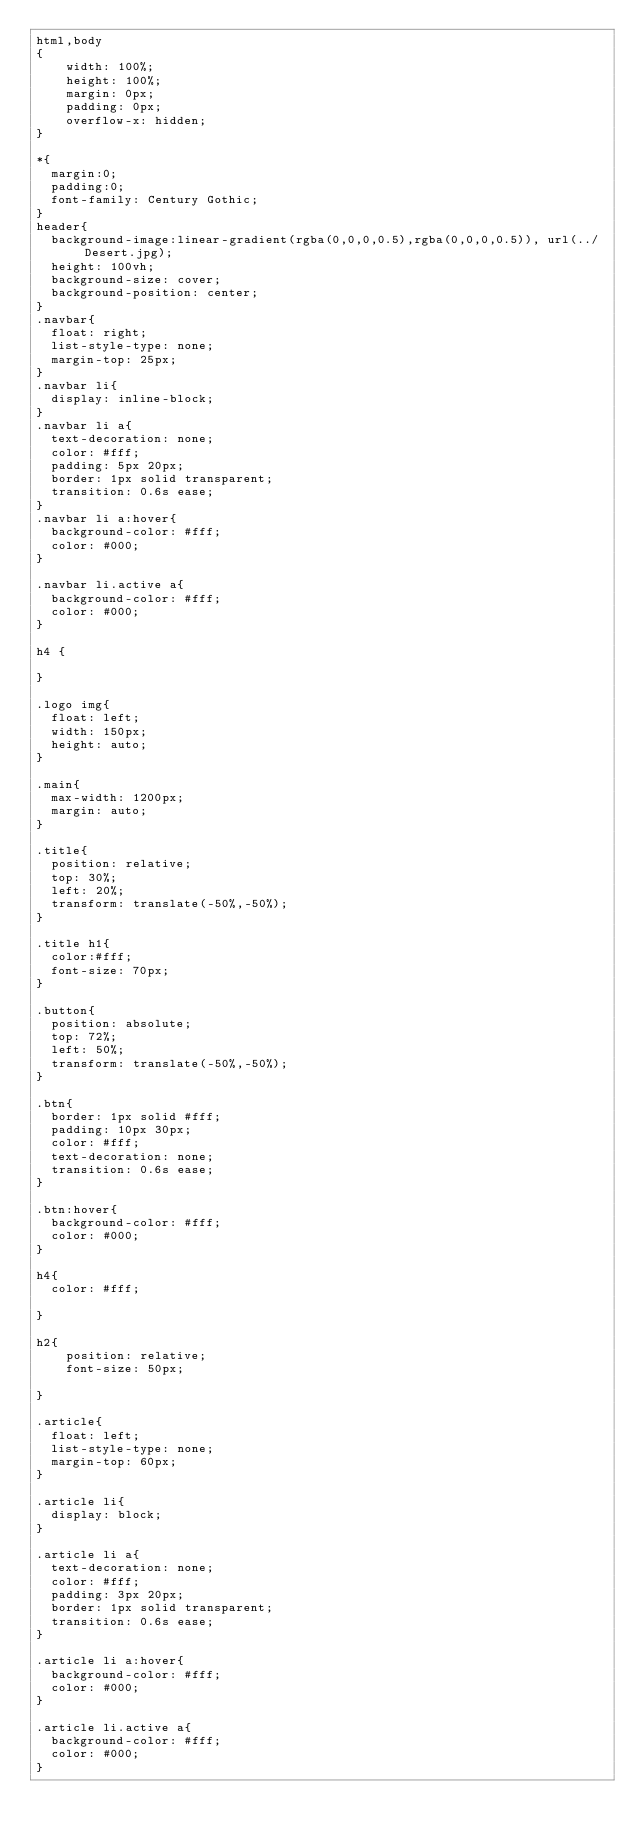Convert code to text. <code><loc_0><loc_0><loc_500><loc_500><_CSS_>html,body
{
    width: 100%;
    height: 100%;
    margin: 0px;
    padding: 0px;
    overflow-x: hidden; 
}

*{
  margin:0;
  padding:0;
  font-family: Century Gothic;
}
header{
	background-image:linear-gradient(rgba(0,0,0,0.5),rgba(0,0,0,0.5)), url(../Desert.jpg);
	height: 100vh;
	background-size: cover;
	background-position: center;
}
.navbar{
	float: right;
	list-style-type: none;
	margin-top: 25px;
}
.navbar li{
	display: inline-block;
}
.navbar li a{
	text-decoration: none;
	color: #fff;
	padding: 5px 20px;
	border: 1px solid transparent;
	transition: 0.6s ease;
}
.navbar li a:hover{
	background-color: #fff;
	color: #000;  
}

.navbar li.active a{
	background-color: #fff;
	color: #000;  
}

h4 {

}

.logo img{
	float: left;
	width: 150px;
	height: auto;
}

.main{
	max-width: 1200px;
	margin: auto;
}

.title{
	position: relative;
	top: 30%;
	left: 20%;
	transform: translate(-50%,-50%);
}

.title h1{
	color:#fff;
	font-size: 70px;
}

.button{
	position: absolute;
	top: 72%;
	left: 50%;
	transform: translate(-50%,-50%);
}

.btn{
	border: 1px solid #fff;
	padding: 10px 30px;
	color: #fff;
	text-decoration: none;
	transition: 0.6s ease;
}

.btn:hover{
	background-color: #fff;
	color: #000;
}

h4{
	color: #fff;
	
}

h2{
    position: relative;
    font-size: 50px;
    
}

.article{
	float: left;
	list-style-type: none;
	margin-top: 60px;
}

.article li{
	display: block;
}

.article li a{
	text-decoration: none;
	color: #fff;
	padding: 3px 20px;
	border: 1px solid transparent;
	transition: 0.6s ease;
}

.article li a:hover{
	background-color: #fff;
	color: #000;
}

.article li.active a{
	background-color: #fff;
	color: #000; 
}
</code> 